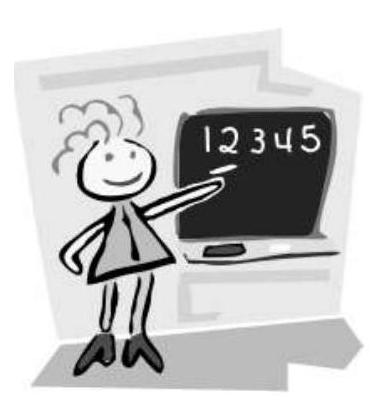Mary has written all the numbers from 1 to 30 . How many times has she written digit 2?
 Answer is 13. 